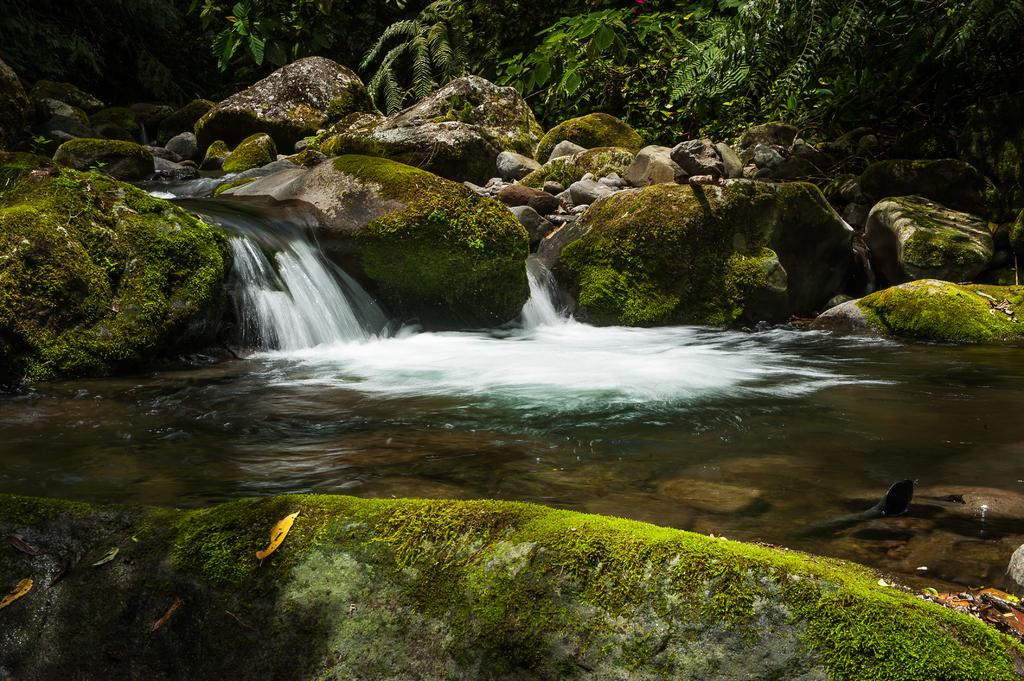What is happening to the water in the image? Water is flowing through stones in the image. What can be found in the center of the image? There is a pond in the center of the image. What type of vegetation is visible at the top of the image? Trees are present at the top of the image. What type of polish is applied to the stones in the image? There is no mention of polish being applied to the stones in the image; they appear to be natural stones. 